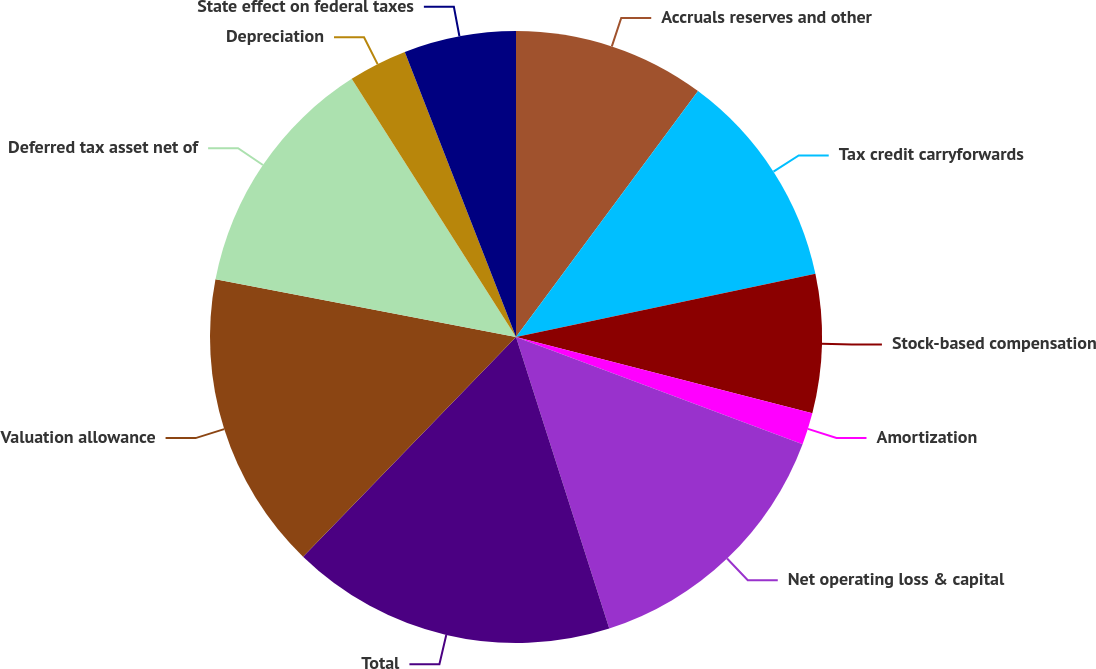Convert chart to OTSL. <chart><loc_0><loc_0><loc_500><loc_500><pie_chart><fcel>Accruals reserves and other<fcel>Tax credit carryforwards<fcel>Stock-based compensation<fcel>Amortization<fcel>Net operating loss & capital<fcel>Total<fcel>Valuation allowance<fcel>Deferred tax asset net of<fcel>Depreciation<fcel>State effect on federal taxes<nl><fcel>10.14%<fcel>11.55%<fcel>7.32%<fcel>1.69%<fcel>14.37%<fcel>17.18%<fcel>15.77%<fcel>12.96%<fcel>3.1%<fcel>5.92%<nl></chart> 